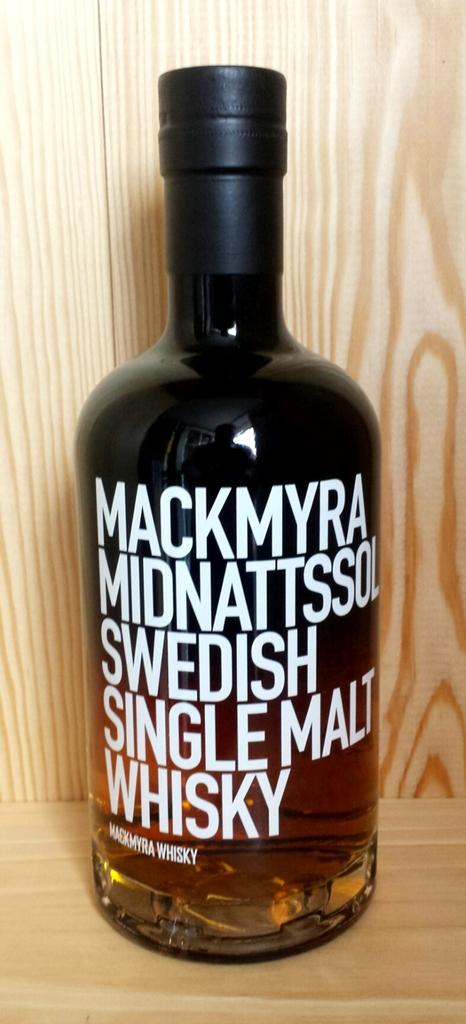What style of whisky is in the bottle?
Your response must be concise. Single malt. What kind of alcohol is this?
Offer a very short reply. Whisky. 